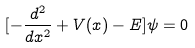<formula> <loc_0><loc_0><loc_500><loc_500>[ - \frac { d ^ { 2 } } { d x ^ { 2 } } + V ( x ) - E ] \psi = 0</formula> 